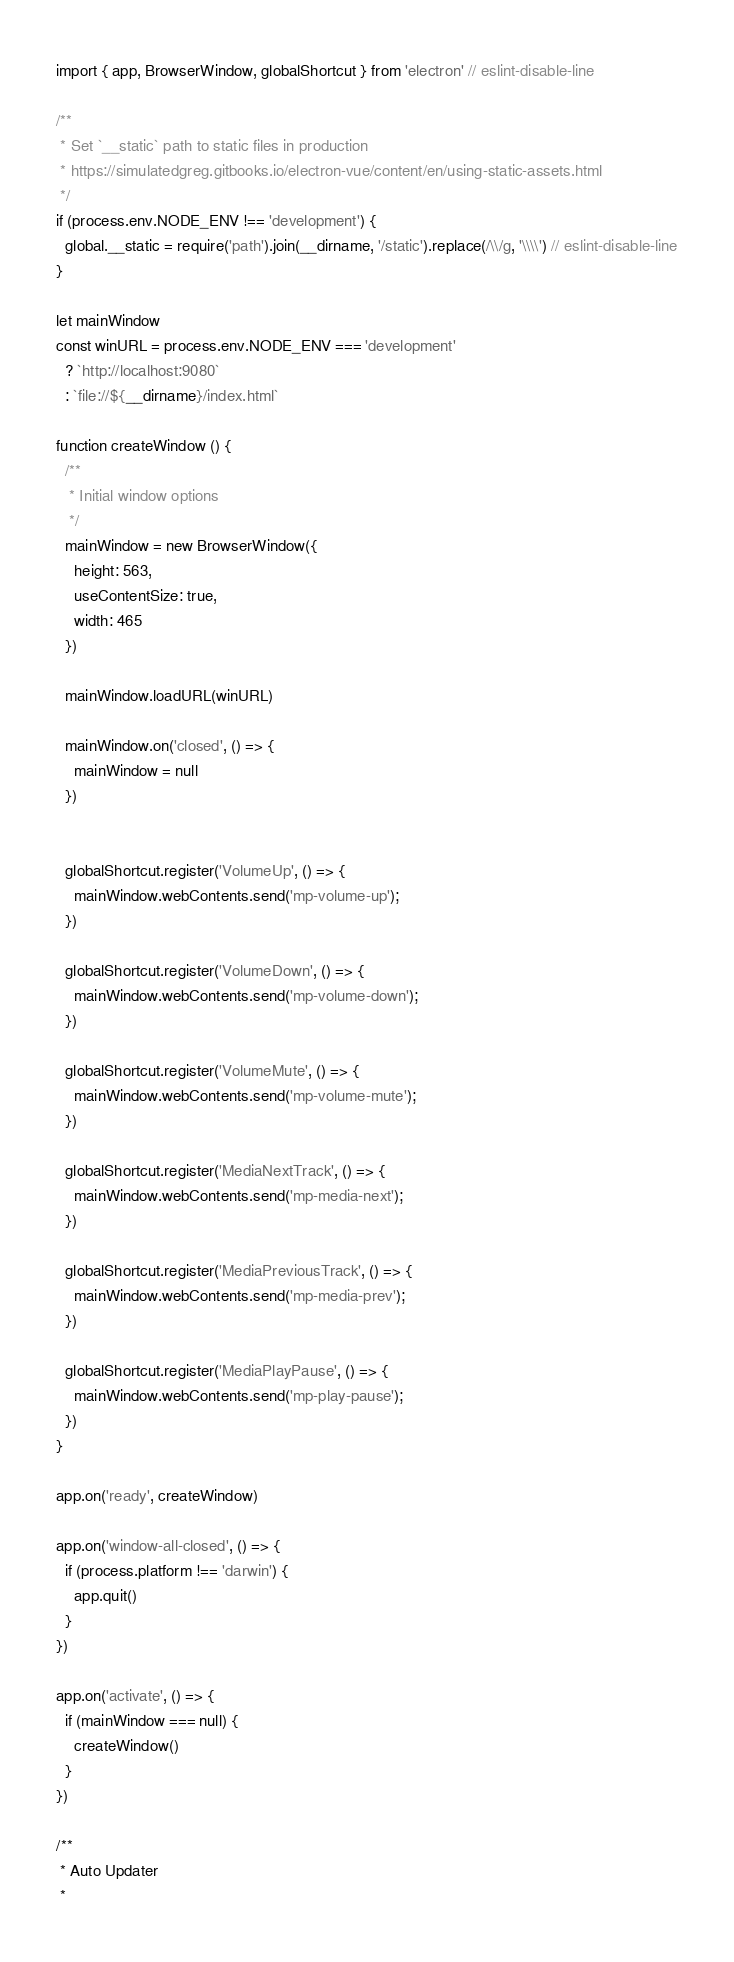Convert code to text. <code><loc_0><loc_0><loc_500><loc_500><_JavaScript_>import { app, BrowserWindow, globalShortcut } from 'electron' // eslint-disable-line

/**
 * Set `__static` path to static files in production
 * https://simulatedgreg.gitbooks.io/electron-vue/content/en/using-static-assets.html
 */
if (process.env.NODE_ENV !== 'development') {
  global.__static = require('path').join(__dirname, '/static').replace(/\\/g, '\\\\') // eslint-disable-line
}

let mainWindow
const winURL = process.env.NODE_ENV === 'development'
  ? `http://localhost:9080`
  : `file://${__dirname}/index.html`

function createWindow () {
  /**
   * Initial window options
   */
  mainWindow = new BrowserWindow({
    height: 563,
    useContentSize: true,
    width: 465
  })

  mainWindow.loadURL(winURL)

  mainWindow.on('closed', () => {
    mainWindow = null
  })


  globalShortcut.register('VolumeUp', () => {
    mainWindow.webContents.send('mp-volume-up');
  })

  globalShortcut.register('VolumeDown', () => {
    mainWindow.webContents.send('mp-volume-down');
  })

  globalShortcut.register('VolumeMute', () => {
    mainWindow.webContents.send('mp-volume-mute');
  })

  globalShortcut.register('MediaNextTrack', () => {
    mainWindow.webContents.send('mp-media-next');
  })

  globalShortcut.register('MediaPreviousTrack', () => {
    mainWindow.webContents.send('mp-media-prev');
  })

  globalShortcut.register('MediaPlayPause', () => {
    mainWindow.webContents.send('mp-play-pause');
  })
}

app.on('ready', createWindow)

app.on('window-all-closed', () => {
  if (process.platform !== 'darwin') {
    app.quit()
  }
})

app.on('activate', () => {
  if (mainWindow === null) {
    createWindow()
  }
})

/**
 * Auto Updater
 *</code> 